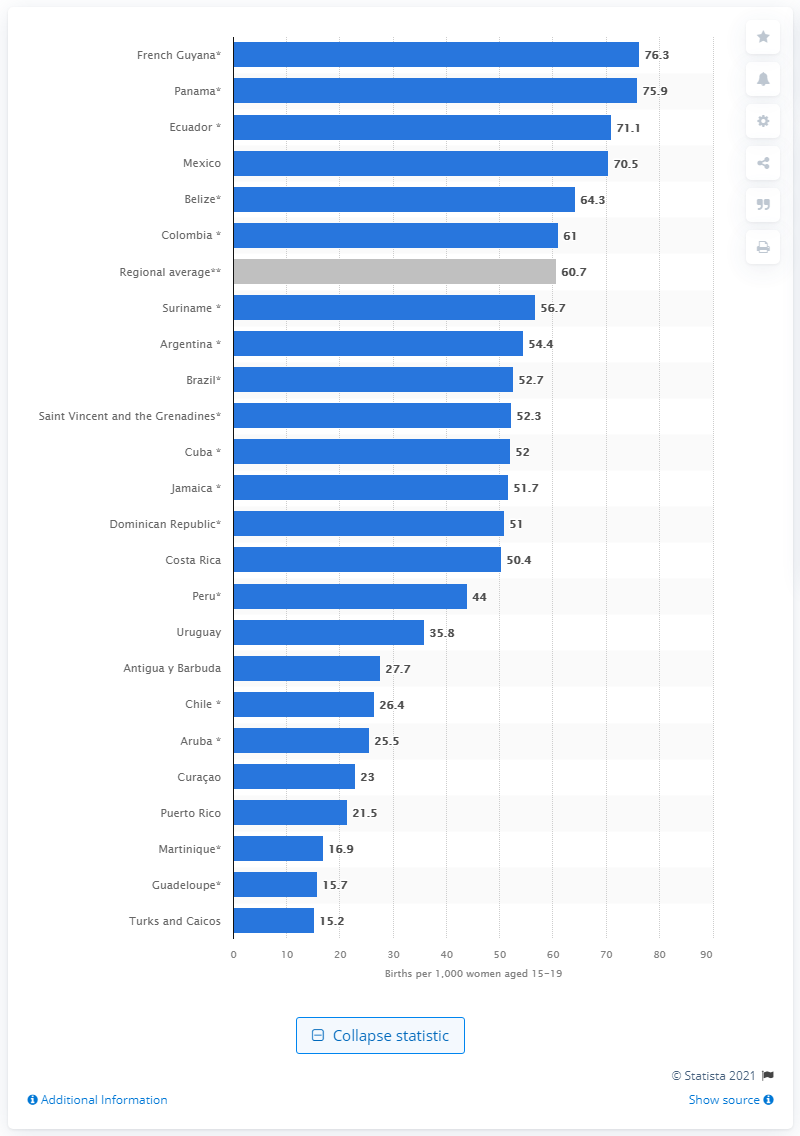Specify some key components in this picture. According to recent data, the average adolescent birth rate in Latin America and the Caribbean is 60.7 births per 1,000 women between the ages of 15 and 19. 